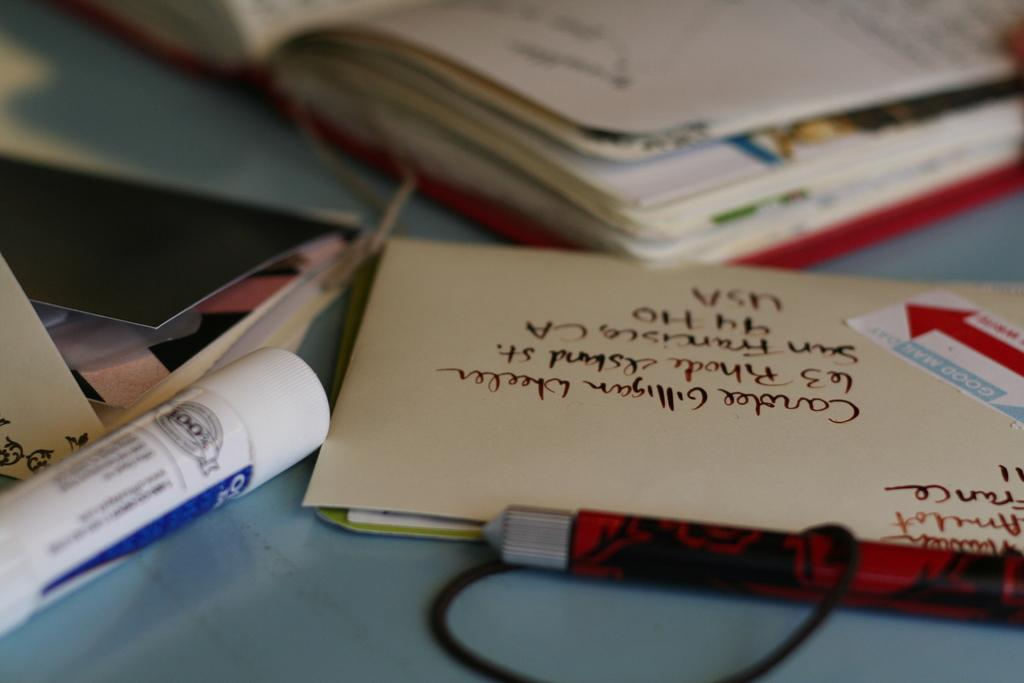<image>
Write a terse but informative summary of the picture. a table with envelops and books and a small circular object that says 100$ on it 